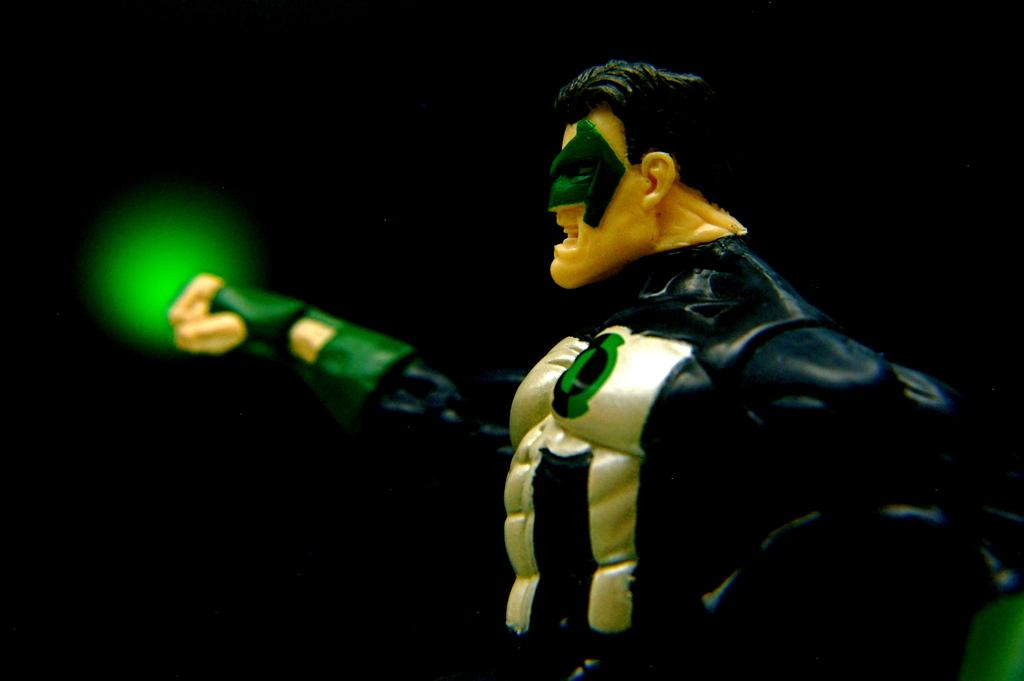What type of object is the main subject of the image? There is a cartoon action figure in the image. What can be seen in the background of the image? There is a green light in the background of the image. What time does the stranger arrive in the image? There is no stranger present in the image, so it is not possible to determine when they might arrive. 